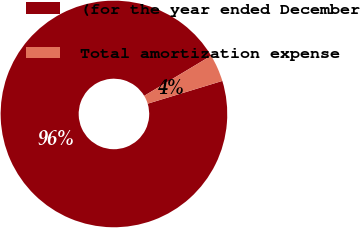<chart> <loc_0><loc_0><loc_500><loc_500><pie_chart><fcel>(for the year ended December<fcel>Total amortization expense<nl><fcel>96.12%<fcel>3.88%<nl></chart> 